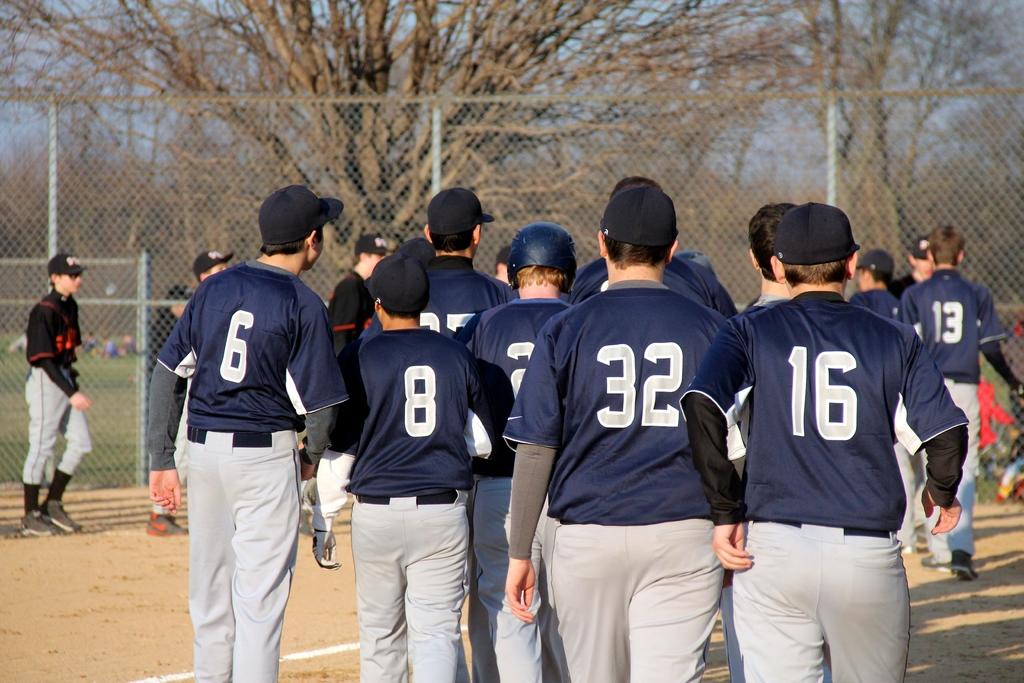What number player is on the far left?
Your answer should be compact. 6. What is the player's number on the far right?
Provide a short and direct response. 16. 